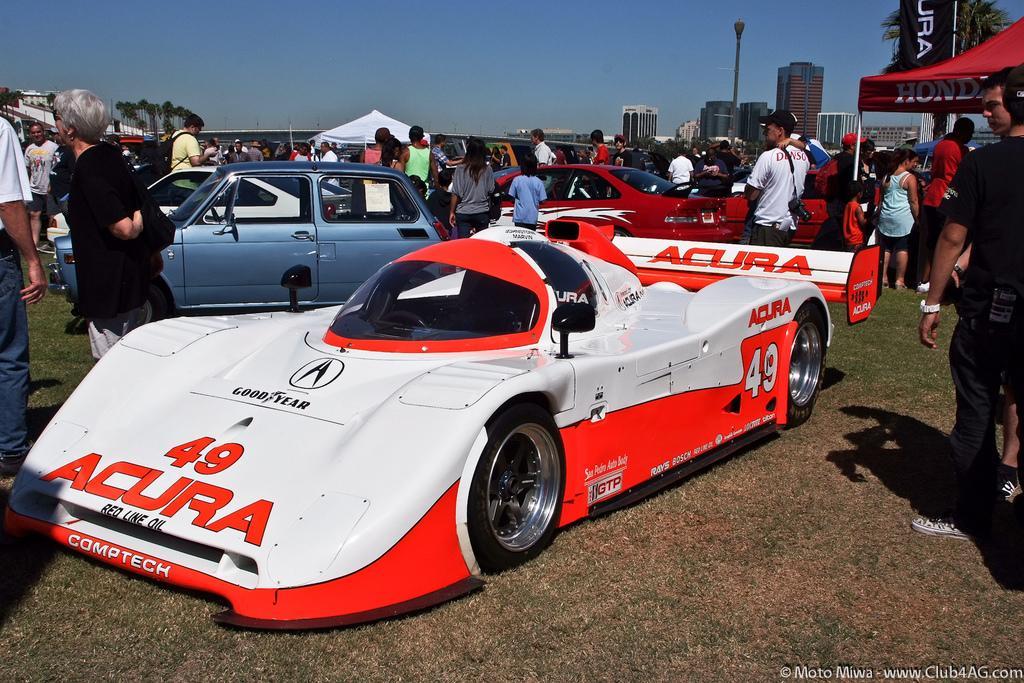Please provide a concise description of this image. This is an outside view. Here I can see many cars on the ground. Along with the cars many people are standing. In the background there are some buildings and trees. At the top of the image I can see the sky. 